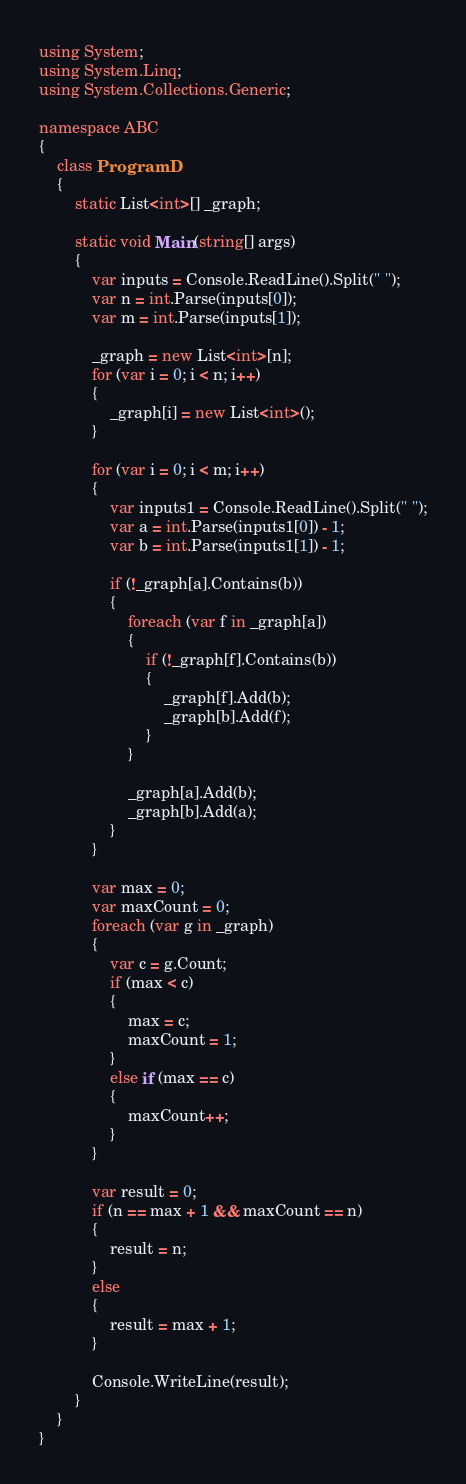Convert code to text. <code><loc_0><loc_0><loc_500><loc_500><_C#_>using System;
using System.Linq;
using System.Collections.Generic;

namespace ABC
{
    class ProgramD
    {
        static List<int>[] _graph;

        static void Main(string[] args)
        {
            var inputs = Console.ReadLine().Split(" ");
            var n = int.Parse(inputs[0]);
            var m = int.Parse(inputs[1]);

            _graph = new List<int>[n];
            for (var i = 0; i < n; i++)
            {
                _graph[i] = new List<int>();
            }

            for (var i = 0; i < m; i++)
            {
                var inputs1 = Console.ReadLine().Split(" ");
                var a = int.Parse(inputs1[0]) - 1;
                var b = int.Parse(inputs1[1]) - 1;

                if (!_graph[a].Contains(b))
                {
                    foreach (var f in _graph[a])
                    {
                        if (!_graph[f].Contains(b))
                        {
                            _graph[f].Add(b);
                            _graph[b].Add(f);
                        }
                    }

                    _graph[a].Add(b);
                    _graph[b].Add(a);
                }
            }

            var max = 0;
            var maxCount = 0;
            foreach (var g in _graph)
            {
                var c = g.Count;
                if (max < c)
                {
                    max = c;
                    maxCount = 1;
                }
                else if (max == c)
                {
                    maxCount++;
                }
            }

            var result = 0;
            if (n == max + 1 && maxCount == n)
            {
                result = n;
            }
            else
            {
                result = max + 1;
            }

            Console.WriteLine(result);
        }
    }
}
</code> 